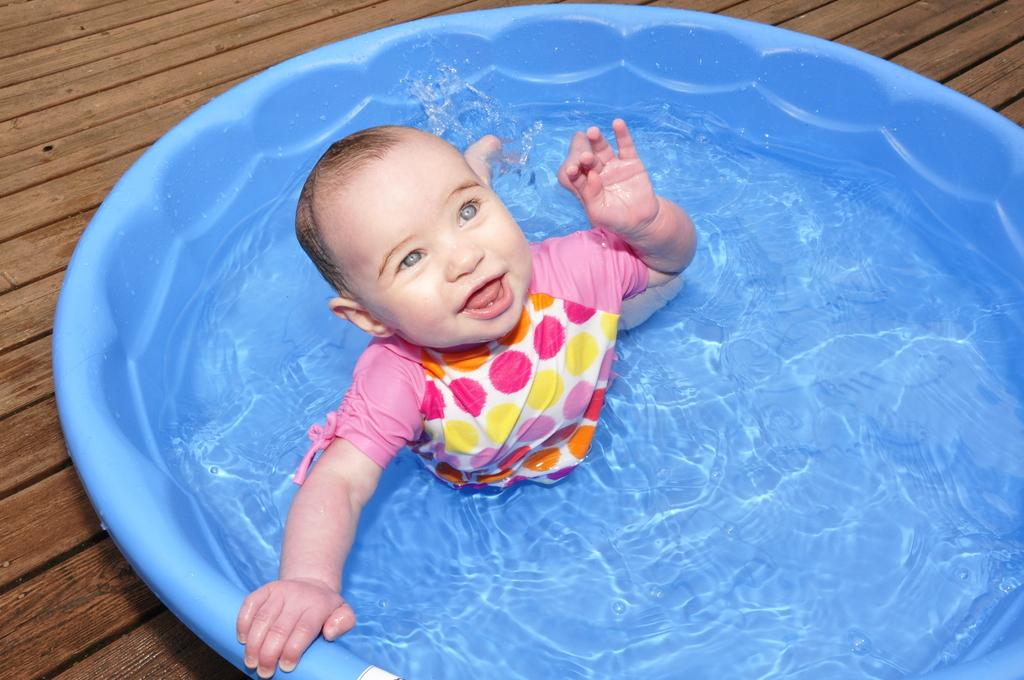What is the main subject of the image? There is a baby in the image. Where is the baby located? The baby is in a tub. What is in the tub with the baby? The tub contains water. What type of flooring is visible in the image? The tub is on a wooden floor. What nerve is responsible for the baby's ability to feel the water in the tub? The image does not provide information about the baby's nerves or their function, so it is not possible to answer this question. 